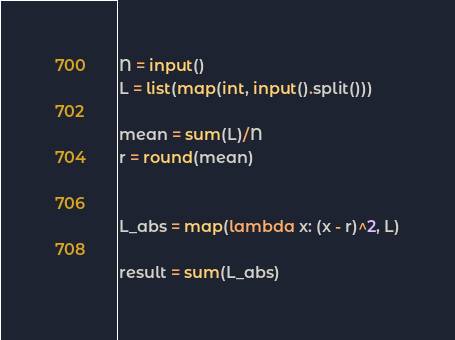Convert code to text. <code><loc_0><loc_0><loc_500><loc_500><_Python_>N = input()
L = list(map(int, input().split()))

mean = sum(L)/N
r = round(mean)


L_abs = map(lambda x: (x - r)^2, L)

result = sum(L_abs)

</code> 